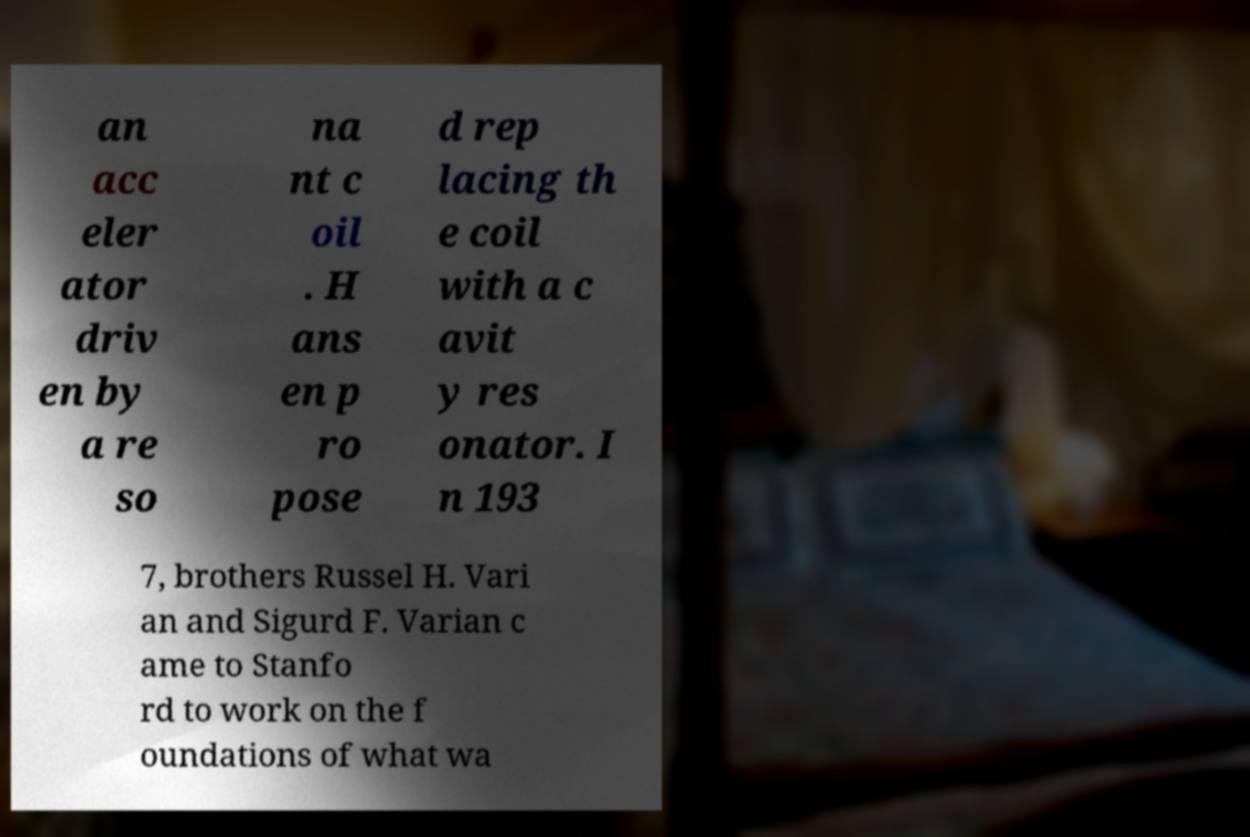What messages or text are displayed in this image? I need them in a readable, typed format. an acc eler ator driv en by a re so na nt c oil . H ans en p ro pose d rep lacing th e coil with a c avit y res onator. I n 193 7, brothers Russel H. Vari an and Sigurd F. Varian c ame to Stanfo rd to work on the f oundations of what wa 